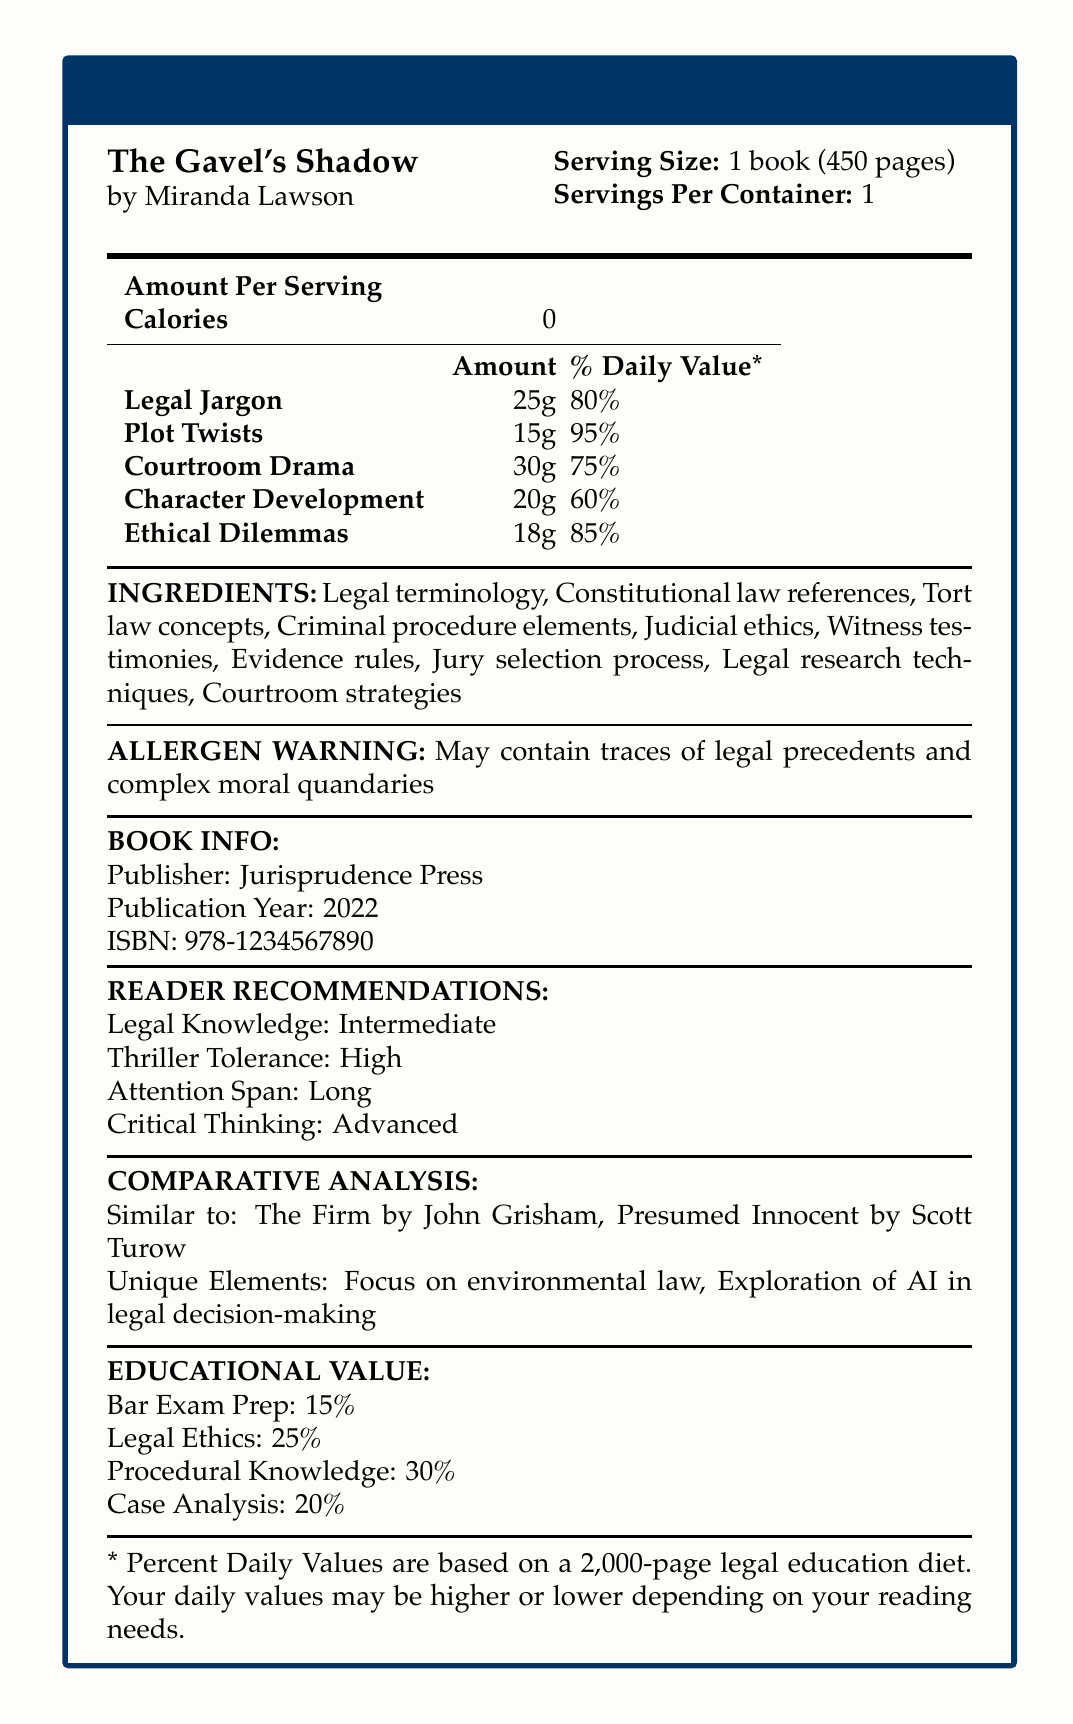What is the serving size for "The Gavel's Shadow"? The document states that the serving size is 1 book consisting of 450 pages.
Answer: 1 book (450 pages) How many servings per container are there for "The Gavel's Shadow"? The document clearly indicates that there is 1 serving per container.
Answer: 1 How many calories are in one serving of "The Gavel's Shadow"? According to the document, the calories per serving are 0.
Answer: 0 What percentage of the daily value does the book's legal jargon provide? The document lists that "Legal Jargon" is 25g, which is 80% of the daily value.
Answer: 80% Which ingredient in "The Gavel's Shadow" has the highest daily value percentage? The document shows "Plot Twists" at 95%, which is the highest daily value percentage.
Answer: Plot Twists What is the main type of drama in "The Gavel's Shadow"? The document indicates "Courtroom Drama" as having 30g with 75% daily value.
Answer: Courtroom Drama Which of the following is a unique element of "The Gavel's Shadow"? A. Constitutional law references B. Exploration of AI in legal decision-making C. Tort law concepts D. Criminal procedure elements The document highlights "Exploration of AI in legal decision-making" as a unique element.
Answer: B What skill level of legal knowledge should a reader have to fully enjoy "The Gavel's Shadow"? A. Beginner B. Intermediate C. Advanced The document recommends that readers have Intermediate legal knowledge.
Answer: B Does the book contain any allergen warnings? The document contains an allergen warning about traces of legal precedents and complex moral quandaries.
Answer: Yes What is the ISBN of "The Gavel's Shadow"? The document lists the ISBN number: 978-1234567890.
Answer: 978-1234567890 Who is the publisher of "The Gavel's Shadow"? The document states that the publisher is Jurisprudence Press.
Answer: Jurisprudence Press How much of the book's educational value is dedicated to Bar Exam Prep? The document mentions that the educational value dedicated to Bar Exam Prep is 15%.
Answer: 15% What is the recommended attention span for readers of "The Gavel's Shadow"? The document specifies that readers should have a long attention span.
Answer: Long Which two books is "The Gavel's Shadow" compared to in terms of similarity? The document compares "The Gavel's Shadow" to "The Firm" by John Grisham and "Presumed Innocent" by Scott Turow.
Answer: The Firm by John Grisham, Presumed Innocent by Scott Turow Describe the main idea of the document. The document is structured like a Nutrition Facts Label, providing a unique and engaging way to present the components and recommendations for "The Gavel's Shadow".
Answer: The main idea of the document is to provide a nutritional-style breakdown and summary of the book "The Gavel's Shadow" by Miranda Lawson. It includes serving size, servings per container, detailed nutritional percentages for various literary elements, ingredients, allergen warning, book information, reader recommendations, comparative analysis, and educational value. Where did the author get their law degree? The document does not provide any information about where the author got their law degree.
Answer: Cannot be determined 